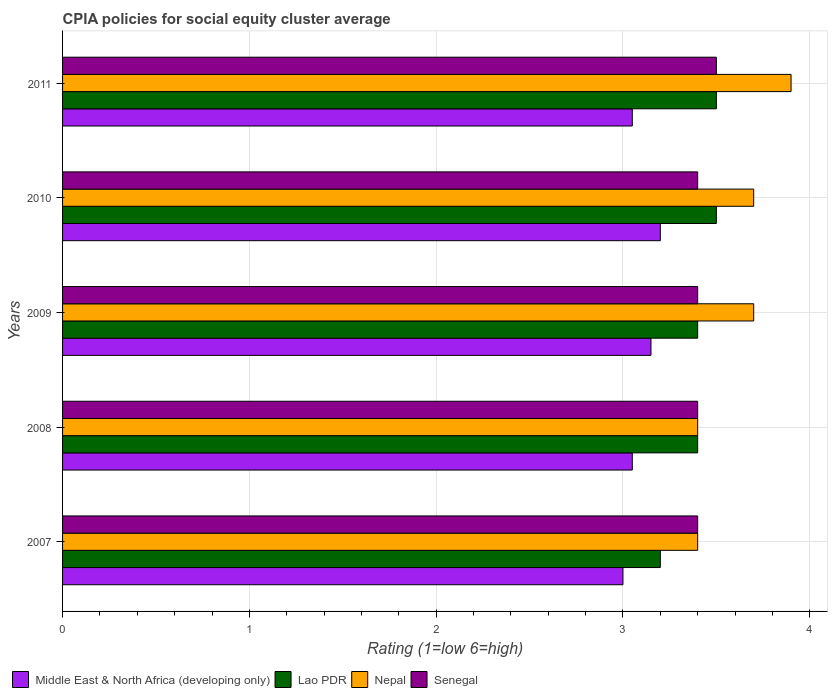Are the number of bars per tick equal to the number of legend labels?
Provide a succinct answer. Yes. Are the number of bars on each tick of the Y-axis equal?
Give a very brief answer. Yes. What is the label of the 5th group of bars from the top?
Ensure brevity in your answer.  2007. What is the CPIA rating in Nepal in 2007?
Ensure brevity in your answer.  3.4. Across all years, what is the minimum CPIA rating in Middle East & North Africa (developing only)?
Ensure brevity in your answer.  3. In which year was the CPIA rating in Nepal maximum?
Give a very brief answer. 2011. In which year was the CPIA rating in Nepal minimum?
Provide a succinct answer. 2007. What is the total CPIA rating in Nepal in the graph?
Your answer should be compact. 18.1. What is the difference between the CPIA rating in Middle East & North Africa (developing only) in 2008 and that in 2011?
Give a very brief answer. 0. What is the difference between the CPIA rating in Middle East & North Africa (developing only) in 2010 and the CPIA rating in Lao PDR in 2011?
Keep it short and to the point. -0.3. What is the average CPIA rating in Senegal per year?
Give a very brief answer. 3.42. In how many years, is the CPIA rating in Nepal greater than 3.4 ?
Give a very brief answer. 3. What is the ratio of the CPIA rating in Lao PDR in 2008 to that in 2011?
Ensure brevity in your answer.  0.97. What is the difference between the highest and the second highest CPIA rating in Senegal?
Give a very brief answer. 0.1. What is the difference between the highest and the lowest CPIA rating in Lao PDR?
Provide a succinct answer. 0.3. In how many years, is the CPIA rating in Lao PDR greater than the average CPIA rating in Lao PDR taken over all years?
Offer a very short reply. 2. Is it the case that in every year, the sum of the CPIA rating in Senegal and CPIA rating in Middle East & North Africa (developing only) is greater than the sum of CPIA rating in Nepal and CPIA rating in Lao PDR?
Ensure brevity in your answer.  No. What does the 3rd bar from the top in 2009 represents?
Your response must be concise. Lao PDR. What does the 3rd bar from the bottom in 2010 represents?
Give a very brief answer. Nepal. How many bars are there?
Keep it short and to the point. 20. How many years are there in the graph?
Ensure brevity in your answer.  5. Does the graph contain any zero values?
Offer a very short reply. No. Where does the legend appear in the graph?
Make the answer very short. Bottom left. What is the title of the graph?
Provide a succinct answer. CPIA policies for social equity cluster average. Does "Solomon Islands" appear as one of the legend labels in the graph?
Provide a succinct answer. No. What is the Rating (1=low 6=high) in Lao PDR in 2007?
Offer a very short reply. 3.2. What is the Rating (1=low 6=high) in Senegal in 2007?
Your answer should be compact. 3.4. What is the Rating (1=low 6=high) in Middle East & North Africa (developing only) in 2008?
Provide a succinct answer. 3.05. What is the Rating (1=low 6=high) in Nepal in 2008?
Your answer should be compact. 3.4. What is the Rating (1=low 6=high) in Middle East & North Africa (developing only) in 2009?
Offer a terse response. 3.15. What is the Rating (1=low 6=high) in Nepal in 2009?
Offer a terse response. 3.7. What is the Rating (1=low 6=high) of Senegal in 2010?
Provide a short and direct response. 3.4. What is the Rating (1=low 6=high) in Middle East & North Africa (developing only) in 2011?
Give a very brief answer. 3.05. What is the Rating (1=low 6=high) of Nepal in 2011?
Your response must be concise. 3.9. Across all years, what is the maximum Rating (1=low 6=high) in Senegal?
Provide a short and direct response. 3.5. Across all years, what is the minimum Rating (1=low 6=high) of Middle East & North Africa (developing only)?
Ensure brevity in your answer.  3. Across all years, what is the minimum Rating (1=low 6=high) of Lao PDR?
Ensure brevity in your answer.  3.2. Across all years, what is the minimum Rating (1=low 6=high) in Nepal?
Give a very brief answer. 3.4. What is the total Rating (1=low 6=high) in Middle East & North Africa (developing only) in the graph?
Provide a short and direct response. 15.45. What is the total Rating (1=low 6=high) in Lao PDR in the graph?
Provide a short and direct response. 17. What is the total Rating (1=low 6=high) in Senegal in the graph?
Provide a short and direct response. 17.1. What is the difference between the Rating (1=low 6=high) in Nepal in 2007 and that in 2008?
Make the answer very short. 0. What is the difference between the Rating (1=low 6=high) of Senegal in 2007 and that in 2008?
Your answer should be very brief. 0. What is the difference between the Rating (1=low 6=high) of Middle East & North Africa (developing only) in 2007 and that in 2009?
Your answer should be compact. -0.15. What is the difference between the Rating (1=low 6=high) in Lao PDR in 2007 and that in 2009?
Provide a short and direct response. -0.2. What is the difference between the Rating (1=low 6=high) in Nepal in 2007 and that in 2009?
Ensure brevity in your answer.  -0.3. What is the difference between the Rating (1=low 6=high) of Senegal in 2007 and that in 2009?
Your response must be concise. 0. What is the difference between the Rating (1=low 6=high) in Lao PDR in 2007 and that in 2010?
Provide a short and direct response. -0.3. What is the difference between the Rating (1=low 6=high) of Nepal in 2007 and that in 2010?
Keep it short and to the point. -0.3. What is the difference between the Rating (1=low 6=high) in Senegal in 2007 and that in 2010?
Make the answer very short. 0. What is the difference between the Rating (1=low 6=high) in Middle East & North Africa (developing only) in 2007 and that in 2011?
Give a very brief answer. -0.05. What is the difference between the Rating (1=low 6=high) in Nepal in 2007 and that in 2011?
Your answer should be very brief. -0.5. What is the difference between the Rating (1=low 6=high) in Senegal in 2007 and that in 2011?
Provide a succinct answer. -0.1. What is the difference between the Rating (1=low 6=high) of Middle East & North Africa (developing only) in 2008 and that in 2009?
Offer a terse response. -0.1. What is the difference between the Rating (1=low 6=high) in Nepal in 2008 and that in 2010?
Your answer should be compact. -0.3. What is the difference between the Rating (1=low 6=high) of Senegal in 2008 and that in 2010?
Provide a succinct answer. 0. What is the difference between the Rating (1=low 6=high) of Lao PDR in 2008 and that in 2011?
Give a very brief answer. -0.1. What is the difference between the Rating (1=low 6=high) of Middle East & North Africa (developing only) in 2009 and that in 2010?
Keep it short and to the point. -0.05. What is the difference between the Rating (1=low 6=high) of Nepal in 2009 and that in 2010?
Make the answer very short. 0. What is the difference between the Rating (1=low 6=high) of Senegal in 2009 and that in 2010?
Keep it short and to the point. 0. What is the difference between the Rating (1=low 6=high) of Middle East & North Africa (developing only) in 2009 and that in 2011?
Your response must be concise. 0.1. What is the difference between the Rating (1=low 6=high) of Nepal in 2009 and that in 2011?
Ensure brevity in your answer.  -0.2. What is the difference between the Rating (1=low 6=high) of Senegal in 2009 and that in 2011?
Keep it short and to the point. -0.1. What is the difference between the Rating (1=low 6=high) of Middle East & North Africa (developing only) in 2010 and that in 2011?
Your response must be concise. 0.15. What is the difference between the Rating (1=low 6=high) of Nepal in 2010 and that in 2011?
Ensure brevity in your answer.  -0.2. What is the difference between the Rating (1=low 6=high) of Senegal in 2010 and that in 2011?
Offer a very short reply. -0.1. What is the difference between the Rating (1=low 6=high) of Middle East & North Africa (developing only) in 2007 and the Rating (1=low 6=high) of Senegal in 2008?
Your answer should be compact. -0.4. What is the difference between the Rating (1=low 6=high) of Lao PDR in 2007 and the Rating (1=low 6=high) of Nepal in 2008?
Your answer should be compact. -0.2. What is the difference between the Rating (1=low 6=high) of Lao PDR in 2007 and the Rating (1=low 6=high) of Senegal in 2008?
Ensure brevity in your answer.  -0.2. What is the difference between the Rating (1=low 6=high) in Nepal in 2007 and the Rating (1=low 6=high) in Senegal in 2008?
Your response must be concise. 0. What is the difference between the Rating (1=low 6=high) in Middle East & North Africa (developing only) in 2007 and the Rating (1=low 6=high) in Nepal in 2009?
Provide a short and direct response. -0.7. What is the difference between the Rating (1=low 6=high) in Middle East & North Africa (developing only) in 2007 and the Rating (1=low 6=high) in Senegal in 2009?
Give a very brief answer. -0.4. What is the difference between the Rating (1=low 6=high) in Lao PDR in 2007 and the Rating (1=low 6=high) in Nepal in 2009?
Make the answer very short. -0.5. What is the difference between the Rating (1=low 6=high) of Nepal in 2007 and the Rating (1=low 6=high) of Senegal in 2009?
Make the answer very short. 0. What is the difference between the Rating (1=low 6=high) in Middle East & North Africa (developing only) in 2007 and the Rating (1=low 6=high) in Senegal in 2010?
Make the answer very short. -0.4. What is the difference between the Rating (1=low 6=high) in Lao PDR in 2007 and the Rating (1=low 6=high) in Nepal in 2010?
Your response must be concise. -0.5. What is the difference between the Rating (1=low 6=high) in Nepal in 2007 and the Rating (1=low 6=high) in Senegal in 2010?
Make the answer very short. 0. What is the difference between the Rating (1=low 6=high) of Middle East & North Africa (developing only) in 2007 and the Rating (1=low 6=high) of Lao PDR in 2011?
Your response must be concise. -0.5. What is the difference between the Rating (1=low 6=high) in Middle East & North Africa (developing only) in 2007 and the Rating (1=low 6=high) in Senegal in 2011?
Provide a short and direct response. -0.5. What is the difference between the Rating (1=low 6=high) of Lao PDR in 2007 and the Rating (1=low 6=high) of Nepal in 2011?
Your response must be concise. -0.7. What is the difference between the Rating (1=low 6=high) of Middle East & North Africa (developing only) in 2008 and the Rating (1=low 6=high) of Lao PDR in 2009?
Offer a very short reply. -0.35. What is the difference between the Rating (1=low 6=high) of Middle East & North Africa (developing only) in 2008 and the Rating (1=low 6=high) of Nepal in 2009?
Make the answer very short. -0.65. What is the difference between the Rating (1=low 6=high) in Middle East & North Africa (developing only) in 2008 and the Rating (1=low 6=high) in Senegal in 2009?
Ensure brevity in your answer.  -0.35. What is the difference between the Rating (1=low 6=high) in Lao PDR in 2008 and the Rating (1=low 6=high) in Senegal in 2009?
Provide a short and direct response. 0. What is the difference between the Rating (1=low 6=high) in Middle East & North Africa (developing only) in 2008 and the Rating (1=low 6=high) in Lao PDR in 2010?
Offer a very short reply. -0.45. What is the difference between the Rating (1=low 6=high) of Middle East & North Africa (developing only) in 2008 and the Rating (1=low 6=high) of Nepal in 2010?
Ensure brevity in your answer.  -0.65. What is the difference between the Rating (1=low 6=high) in Middle East & North Africa (developing only) in 2008 and the Rating (1=low 6=high) in Senegal in 2010?
Provide a short and direct response. -0.35. What is the difference between the Rating (1=low 6=high) of Nepal in 2008 and the Rating (1=low 6=high) of Senegal in 2010?
Give a very brief answer. 0. What is the difference between the Rating (1=low 6=high) of Middle East & North Africa (developing only) in 2008 and the Rating (1=low 6=high) of Lao PDR in 2011?
Your response must be concise. -0.45. What is the difference between the Rating (1=low 6=high) of Middle East & North Africa (developing only) in 2008 and the Rating (1=low 6=high) of Nepal in 2011?
Provide a short and direct response. -0.85. What is the difference between the Rating (1=low 6=high) in Middle East & North Africa (developing only) in 2008 and the Rating (1=low 6=high) in Senegal in 2011?
Give a very brief answer. -0.45. What is the difference between the Rating (1=low 6=high) of Lao PDR in 2008 and the Rating (1=low 6=high) of Nepal in 2011?
Your response must be concise. -0.5. What is the difference between the Rating (1=low 6=high) in Middle East & North Africa (developing only) in 2009 and the Rating (1=low 6=high) in Lao PDR in 2010?
Provide a succinct answer. -0.35. What is the difference between the Rating (1=low 6=high) of Middle East & North Africa (developing only) in 2009 and the Rating (1=low 6=high) of Nepal in 2010?
Your response must be concise. -0.55. What is the difference between the Rating (1=low 6=high) in Middle East & North Africa (developing only) in 2009 and the Rating (1=low 6=high) in Senegal in 2010?
Your response must be concise. -0.25. What is the difference between the Rating (1=low 6=high) of Nepal in 2009 and the Rating (1=low 6=high) of Senegal in 2010?
Make the answer very short. 0.3. What is the difference between the Rating (1=low 6=high) of Middle East & North Africa (developing only) in 2009 and the Rating (1=low 6=high) of Lao PDR in 2011?
Give a very brief answer. -0.35. What is the difference between the Rating (1=low 6=high) of Middle East & North Africa (developing only) in 2009 and the Rating (1=low 6=high) of Nepal in 2011?
Offer a very short reply. -0.75. What is the difference between the Rating (1=low 6=high) of Middle East & North Africa (developing only) in 2009 and the Rating (1=low 6=high) of Senegal in 2011?
Give a very brief answer. -0.35. What is the difference between the Rating (1=low 6=high) of Lao PDR in 2009 and the Rating (1=low 6=high) of Nepal in 2011?
Your answer should be compact. -0.5. What is the difference between the Rating (1=low 6=high) in Lao PDR in 2009 and the Rating (1=low 6=high) in Senegal in 2011?
Offer a very short reply. -0.1. What is the difference between the Rating (1=low 6=high) in Nepal in 2009 and the Rating (1=low 6=high) in Senegal in 2011?
Ensure brevity in your answer.  0.2. What is the difference between the Rating (1=low 6=high) in Middle East & North Africa (developing only) in 2010 and the Rating (1=low 6=high) in Lao PDR in 2011?
Provide a short and direct response. -0.3. What is the difference between the Rating (1=low 6=high) in Lao PDR in 2010 and the Rating (1=low 6=high) in Nepal in 2011?
Your answer should be compact. -0.4. What is the difference between the Rating (1=low 6=high) in Lao PDR in 2010 and the Rating (1=low 6=high) in Senegal in 2011?
Provide a succinct answer. 0. What is the difference between the Rating (1=low 6=high) of Nepal in 2010 and the Rating (1=low 6=high) of Senegal in 2011?
Your response must be concise. 0.2. What is the average Rating (1=low 6=high) in Middle East & North Africa (developing only) per year?
Provide a short and direct response. 3.09. What is the average Rating (1=low 6=high) of Nepal per year?
Make the answer very short. 3.62. What is the average Rating (1=low 6=high) of Senegal per year?
Provide a succinct answer. 3.42. In the year 2007, what is the difference between the Rating (1=low 6=high) of Middle East & North Africa (developing only) and Rating (1=low 6=high) of Lao PDR?
Give a very brief answer. -0.2. In the year 2007, what is the difference between the Rating (1=low 6=high) in Middle East & North Africa (developing only) and Rating (1=low 6=high) in Nepal?
Provide a short and direct response. -0.4. In the year 2007, what is the difference between the Rating (1=low 6=high) in Middle East & North Africa (developing only) and Rating (1=low 6=high) in Senegal?
Keep it short and to the point. -0.4. In the year 2007, what is the difference between the Rating (1=low 6=high) of Lao PDR and Rating (1=low 6=high) of Nepal?
Ensure brevity in your answer.  -0.2. In the year 2007, what is the difference between the Rating (1=low 6=high) in Lao PDR and Rating (1=low 6=high) in Senegal?
Ensure brevity in your answer.  -0.2. In the year 2007, what is the difference between the Rating (1=low 6=high) in Nepal and Rating (1=low 6=high) in Senegal?
Your answer should be very brief. 0. In the year 2008, what is the difference between the Rating (1=low 6=high) of Middle East & North Africa (developing only) and Rating (1=low 6=high) of Lao PDR?
Offer a very short reply. -0.35. In the year 2008, what is the difference between the Rating (1=low 6=high) of Middle East & North Africa (developing only) and Rating (1=low 6=high) of Nepal?
Your answer should be compact. -0.35. In the year 2008, what is the difference between the Rating (1=low 6=high) in Middle East & North Africa (developing only) and Rating (1=low 6=high) in Senegal?
Make the answer very short. -0.35. In the year 2008, what is the difference between the Rating (1=low 6=high) in Lao PDR and Rating (1=low 6=high) in Senegal?
Give a very brief answer. 0. In the year 2009, what is the difference between the Rating (1=low 6=high) of Middle East & North Africa (developing only) and Rating (1=low 6=high) of Lao PDR?
Give a very brief answer. -0.25. In the year 2009, what is the difference between the Rating (1=low 6=high) in Middle East & North Africa (developing only) and Rating (1=low 6=high) in Nepal?
Your answer should be compact. -0.55. In the year 2009, what is the difference between the Rating (1=low 6=high) of Lao PDR and Rating (1=low 6=high) of Senegal?
Your answer should be very brief. 0. In the year 2010, what is the difference between the Rating (1=low 6=high) of Middle East & North Africa (developing only) and Rating (1=low 6=high) of Senegal?
Make the answer very short. -0.2. In the year 2010, what is the difference between the Rating (1=low 6=high) of Lao PDR and Rating (1=low 6=high) of Nepal?
Offer a very short reply. -0.2. In the year 2010, what is the difference between the Rating (1=low 6=high) of Lao PDR and Rating (1=low 6=high) of Senegal?
Keep it short and to the point. 0.1. In the year 2010, what is the difference between the Rating (1=low 6=high) in Nepal and Rating (1=low 6=high) in Senegal?
Your response must be concise. 0.3. In the year 2011, what is the difference between the Rating (1=low 6=high) in Middle East & North Africa (developing only) and Rating (1=low 6=high) in Lao PDR?
Offer a terse response. -0.45. In the year 2011, what is the difference between the Rating (1=low 6=high) of Middle East & North Africa (developing only) and Rating (1=low 6=high) of Nepal?
Provide a succinct answer. -0.85. In the year 2011, what is the difference between the Rating (1=low 6=high) of Middle East & North Africa (developing only) and Rating (1=low 6=high) of Senegal?
Make the answer very short. -0.45. In the year 2011, what is the difference between the Rating (1=low 6=high) in Lao PDR and Rating (1=low 6=high) in Nepal?
Give a very brief answer. -0.4. In the year 2011, what is the difference between the Rating (1=low 6=high) in Lao PDR and Rating (1=low 6=high) in Senegal?
Keep it short and to the point. 0. In the year 2011, what is the difference between the Rating (1=low 6=high) in Nepal and Rating (1=low 6=high) in Senegal?
Offer a terse response. 0.4. What is the ratio of the Rating (1=low 6=high) in Middle East & North Africa (developing only) in 2007 to that in 2008?
Your answer should be compact. 0.98. What is the ratio of the Rating (1=low 6=high) in Nepal in 2007 to that in 2008?
Provide a short and direct response. 1. What is the ratio of the Rating (1=low 6=high) of Senegal in 2007 to that in 2008?
Your response must be concise. 1. What is the ratio of the Rating (1=low 6=high) of Lao PDR in 2007 to that in 2009?
Provide a short and direct response. 0.94. What is the ratio of the Rating (1=low 6=high) in Nepal in 2007 to that in 2009?
Offer a very short reply. 0.92. What is the ratio of the Rating (1=low 6=high) in Lao PDR in 2007 to that in 2010?
Your answer should be very brief. 0.91. What is the ratio of the Rating (1=low 6=high) in Nepal in 2007 to that in 2010?
Your response must be concise. 0.92. What is the ratio of the Rating (1=low 6=high) in Middle East & North Africa (developing only) in 2007 to that in 2011?
Ensure brevity in your answer.  0.98. What is the ratio of the Rating (1=low 6=high) in Lao PDR in 2007 to that in 2011?
Provide a short and direct response. 0.91. What is the ratio of the Rating (1=low 6=high) in Nepal in 2007 to that in 2011?
Keep it short and to the point. 0.87. What is the ratio of the Rating (1=low 6=high) in Senegal in 2007 to that in 2011?
Offer a very short reply. 0.97. What is the ratio of the Rating (1=low 6=high) of Middle East & North Africa (developing only) in 2008 to that in 2009?
Provide a succinct answer. 0.97. What is the ratio of the Rating (1=low 6=high) of Nepal in 2008 to that in 2009?
Provide a short and direct response. 0.92. What is the ratio of the Rating (1=low 6=high) in Senegal in 2008 to that in 2009?
Offer a terse response. 1. What is the ratio of the Rating (1=low 6=high) of Middle East & North Africa (developing only) in 2008 to that in 2010?
Make the answer very short. 0.95. What is the ratio of the Rating (1=low 6=high) of Lao PDR in 2008 to that in 2010?
Provide a succinct answer. 0.97. What is the ratio of the Rating (1=low 6=high) of Nepal in 2008 to that in 2010?
Offer a very short reply. 0.92. What is the ratio of the Rating (1=low 6=high) of Senegal in 2008 to that in 2010?
Make the answer very short. 1. What is the ratio of the Rating (1=low 6=high) in Middle East & North Africa (developing only) in 2008 to that in 2011?
Offer a very short reply. 1. What is the ratio of the Rating (1=low 6=high) in Lao PDR in 2008 to that in 2011?
Give a very brief answer. 0.97. What is the ratio of the Rating (1=low 6=high) of Nepal in 2008 to that in 2011?
Make the answer very short. 0.87. What is the ratio of the Rating (1=low 6=high) in Senegal in 2008 to that in 2011?
Your answer should be very brief. 0.97. What is the ratio of the Rating (1=low 6=high) in Middle East & North Africa (developing only) in 2009 to that in 2010?
Provide a short and direct response. 0.98. What is the ratio of the Rating (1=low 6=high) in Lao PDR in 2009 to that in 2010?
Keep it short and to the point. 0.97. What is the ratio of the Rating (1=low 6=high) of Nepal in 2009 to that in 2010?
Your answer should be very brief. 1. What is the ratio of the Rating (1=low 6=high) in Middle East & North Africa (developing only) in 2009 to that in 2011?
Give a very brief answer. 1.03. What is the ratio of the Rating (1=low 6=high) in Lao PDR in 2009 to that in 2011?
Make the answer very short. 0.97. What is the ratio of the Rating (1=low 6=high) in Nepal in 2009 to that in 2011?
Your answer should be compact. 0.95. What is the ratio of the Rating (1=low 6=high) of Senegal in 2009 to that in 2011?
Offer a very short reply. 0.97. What is the ratio of the Rating (1=low 6=high) in Middle East & North Africa (developing only) in 2010 to that in 2011?
Your answer should be compact. 1.05. What is the ratio of the Rating (1=low 6=high) of Nepal in 2010 to that in 2011?
Make the answer very short. 0.95. What is the ratio of the Rating (1=low 6=high) of Senegal in 2010 to that in 2011?
Provide a succinct answer. 0.97. What is the difference between the highest and the second highest Rating (1=low 6=high) in Middle East & North Africa (developing only)?
Provide a succinct answer. 0.05. What is the difference between the highest and the second highest Rating (1=low 6=high) of Nepal?
Provide a succinct answer. 0.2. What is the difference between the highest and the lowest Rating (1=low 6=high) in Lao PDR?
Offer a terse response. 0.3. What is the difference between the highest and the lowest Rating (1=low 6=high) of Senegal?
Provide a succinct answer. 0.1. 